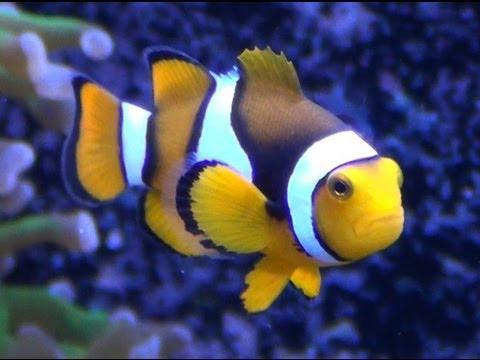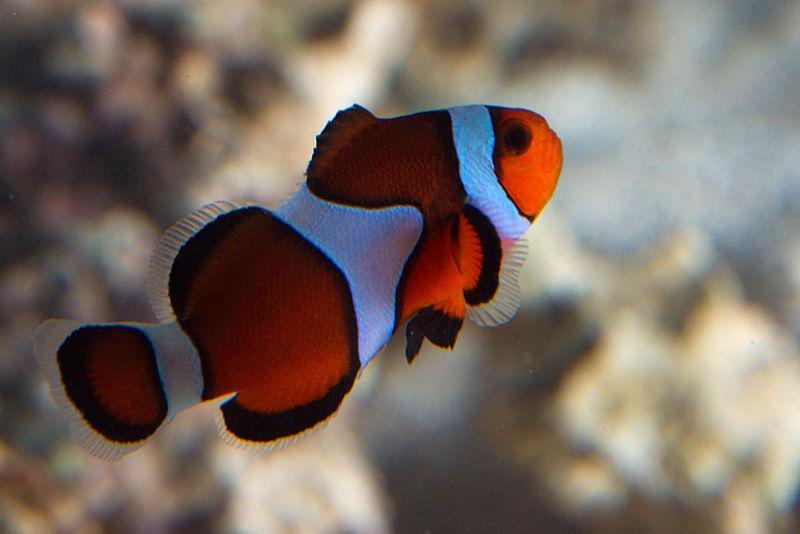The first image is the image on the left, the second image is the image on the right. For the images shown, is this caption "The images show a total of two orange-faced fish swimming rightward." true? Answer yes or no. No. 